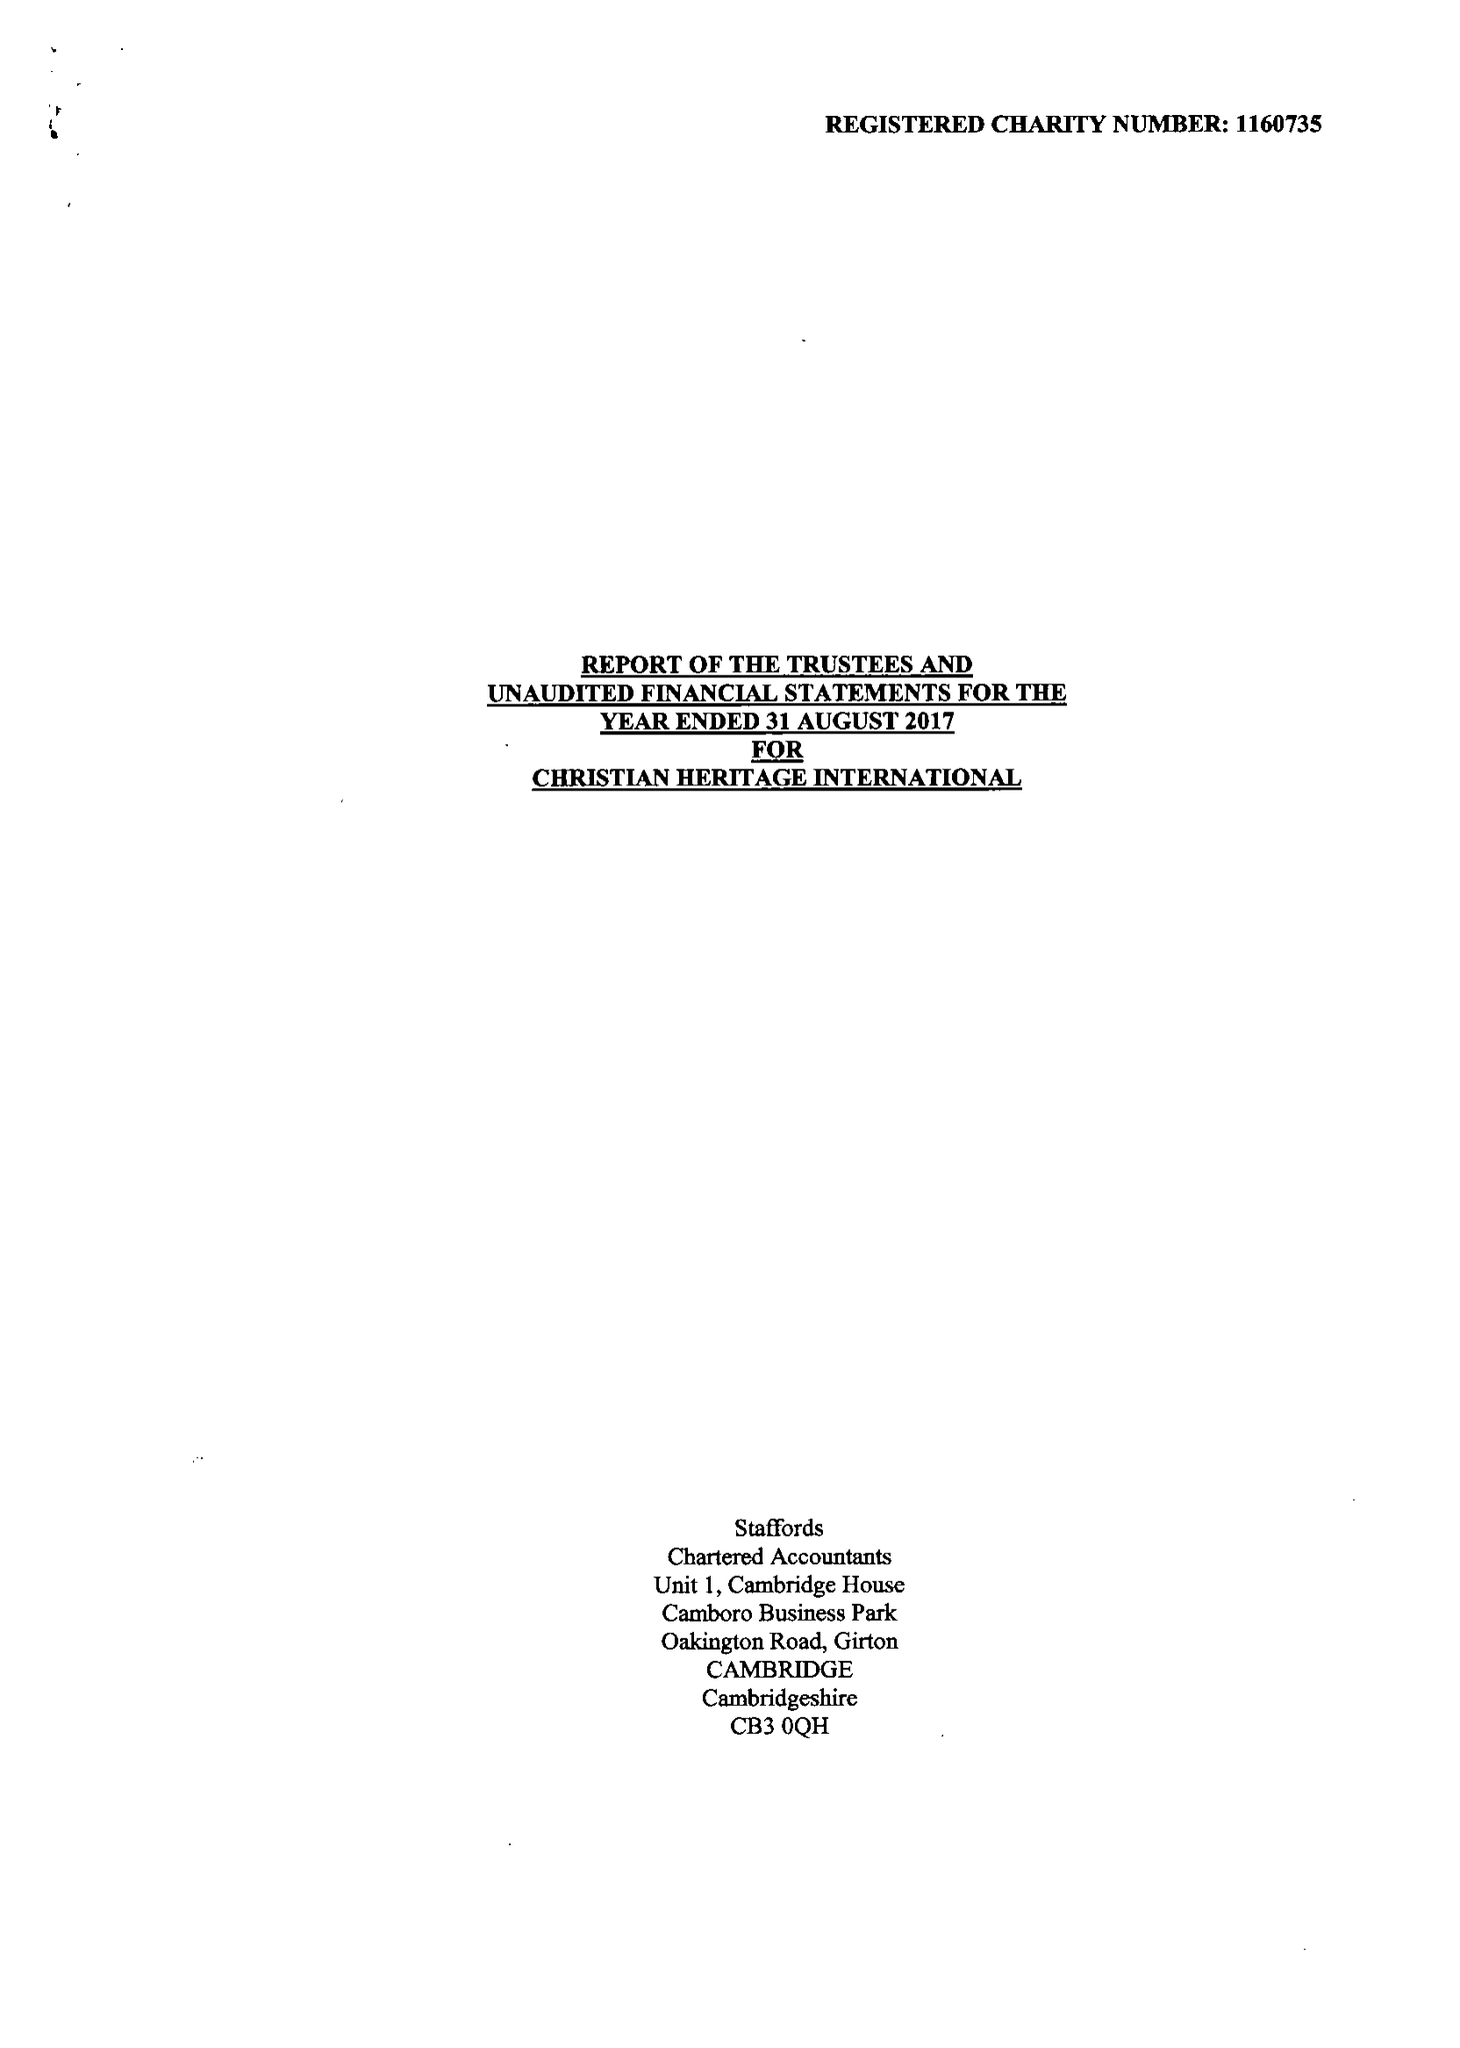What is the value for the address__postcode?
Answer the question using a single word or phrase. HA6 2UR 